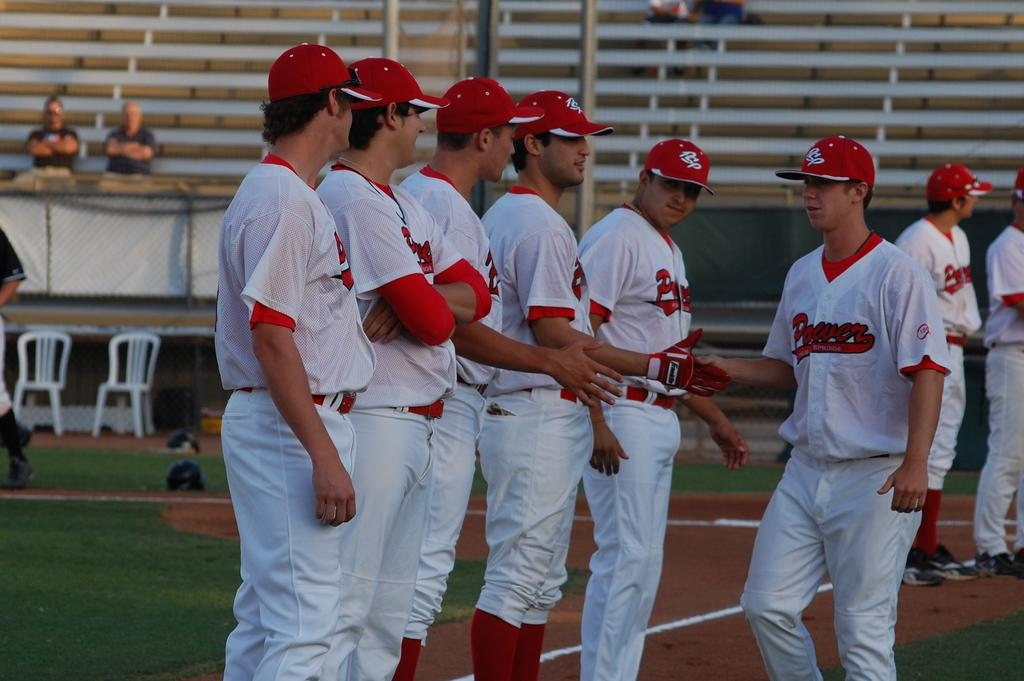<image>
Share a concise interpretation of the image provided. A row of Power baseball players shake hands with another Power player in front of an almost empty stadium. 